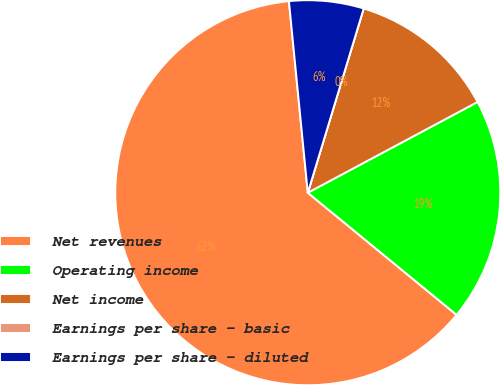<chart> <loc_0><loc_0><loc_500><loc_500><pie_chart><fcel>Net revenues<fcel>Operating income<fcel>Net income<fcel>Earnings per share - basic<fcel>Earnings per share - diluted<nl><fcel>62.5%<fcel>18.75%<fcel>12.5%<fcel>0.0%<fcel>6.25%<nl></chart> 